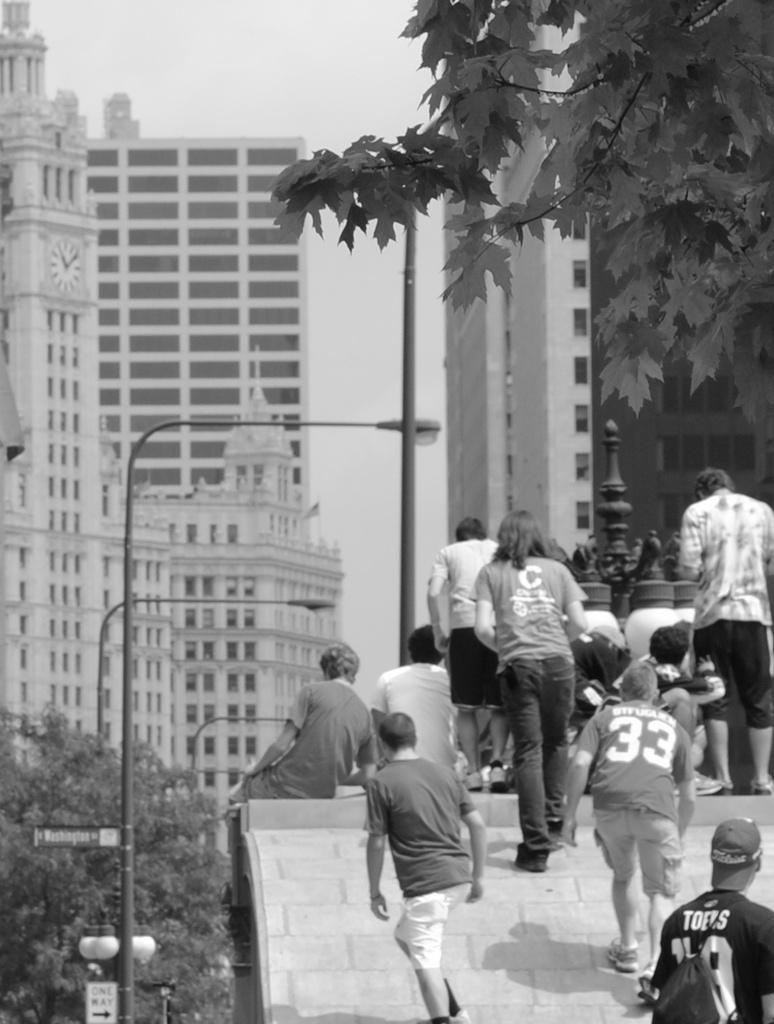What number is on the man's shirt?
Offer a very short reply. 33. Is a man wearing a 33 shirt?
Make the answer very short. Yes. 